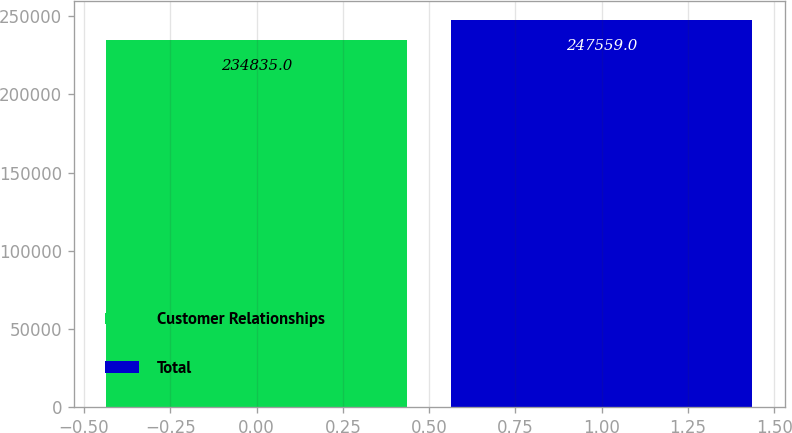Convert chart to OTSL. <chart><loc_0><loc_0><loc_500><loc_500><bar_chart><fcel>Customer Relationships<fcel>Total<nl><fcel>234835<fcel>247559<nl></chart> 